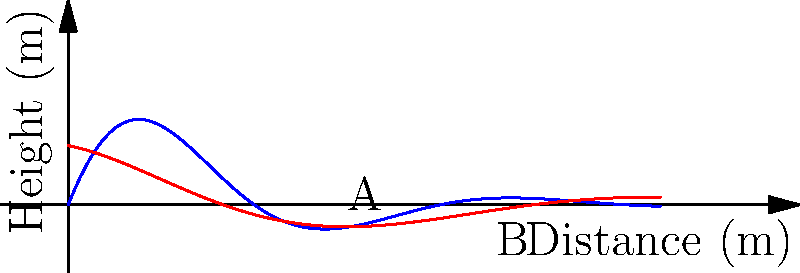The graph shows two vector trajectories modeling seed dispersal for an endangered Tasmanian plant species. The blue curve represents wind-dispersed seeds, while the red curve represents animal-dispersed seeds. Point A is on the blue curve at x = 10, and point B is on the red curve at x = 15. Calculate the magnitude of the displacement vector from point A to point B. To find the magnitude of the displacement vector from point A to point B, we need to follow these steps:

1. Determine the coordinates of points A and B:
   Point A: (10, f(10))
   Point B: (15, g(15))

2. Calculate f(10) and g(15):
   f(10) = 5 * exp(-0.2 * 10) * sin(0.5 * 10) ≈ 0.84
   g(15) = 2 * exp(-0.1 * 15) * cos(0.3 * 15) ≈ 0.22

3. Now we have the coordinates:
   A (10, 0.84)
   B (15, 0.22)

4. Calculate the displacement vector:
   $\vec{AB} = (15 - 10, 0.22 - 0.84) = (5, -0.62)$

5. Use the Pythagorean theorem to find the magnitude of the displacement vector:
   $|\vec{AB}| = \sqrt{(5)^2 + (-0.62)^2}$
   $|\vec{AB}| = \sqrt{25 + 0.3844}$
   $|\vec{AB}| = \sqrt{25.3844}$
   $|\vec{AB}| \approx 5.04$

Therefore, the magnitude of the displacement vector from point A to point B is approximately 5.04 meters.
Answer: 5.04 m 